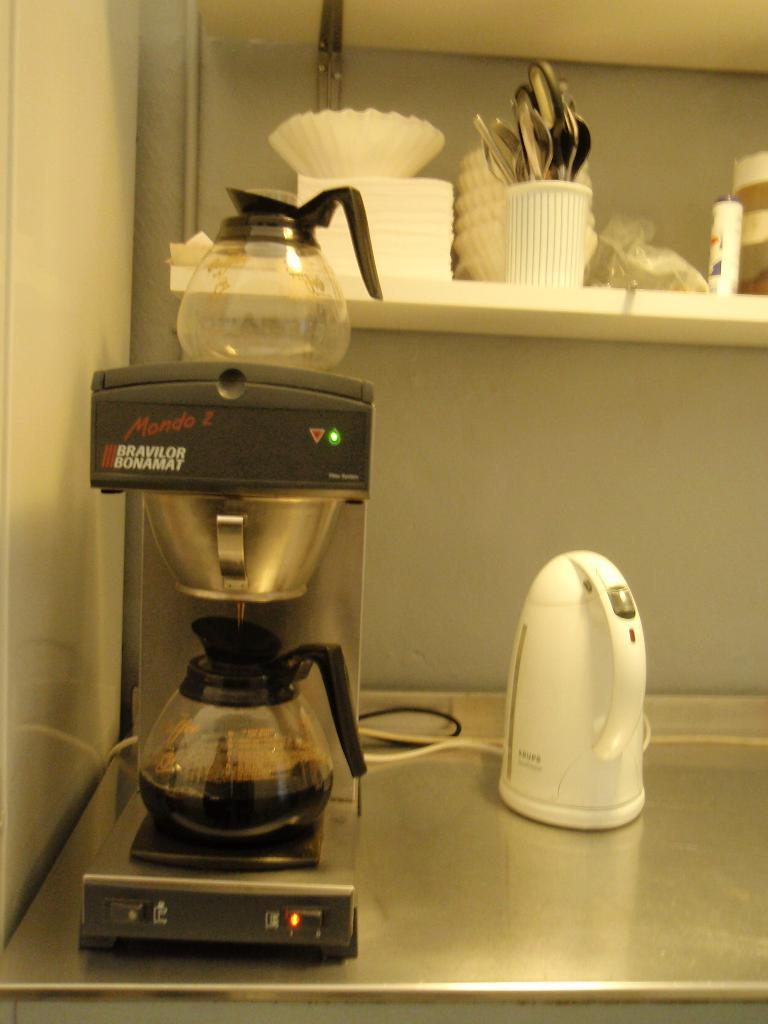<image>
Share a concise interpretation of the image provided. A Bravilor Bonamat filter coffee machine from Mondo Z 